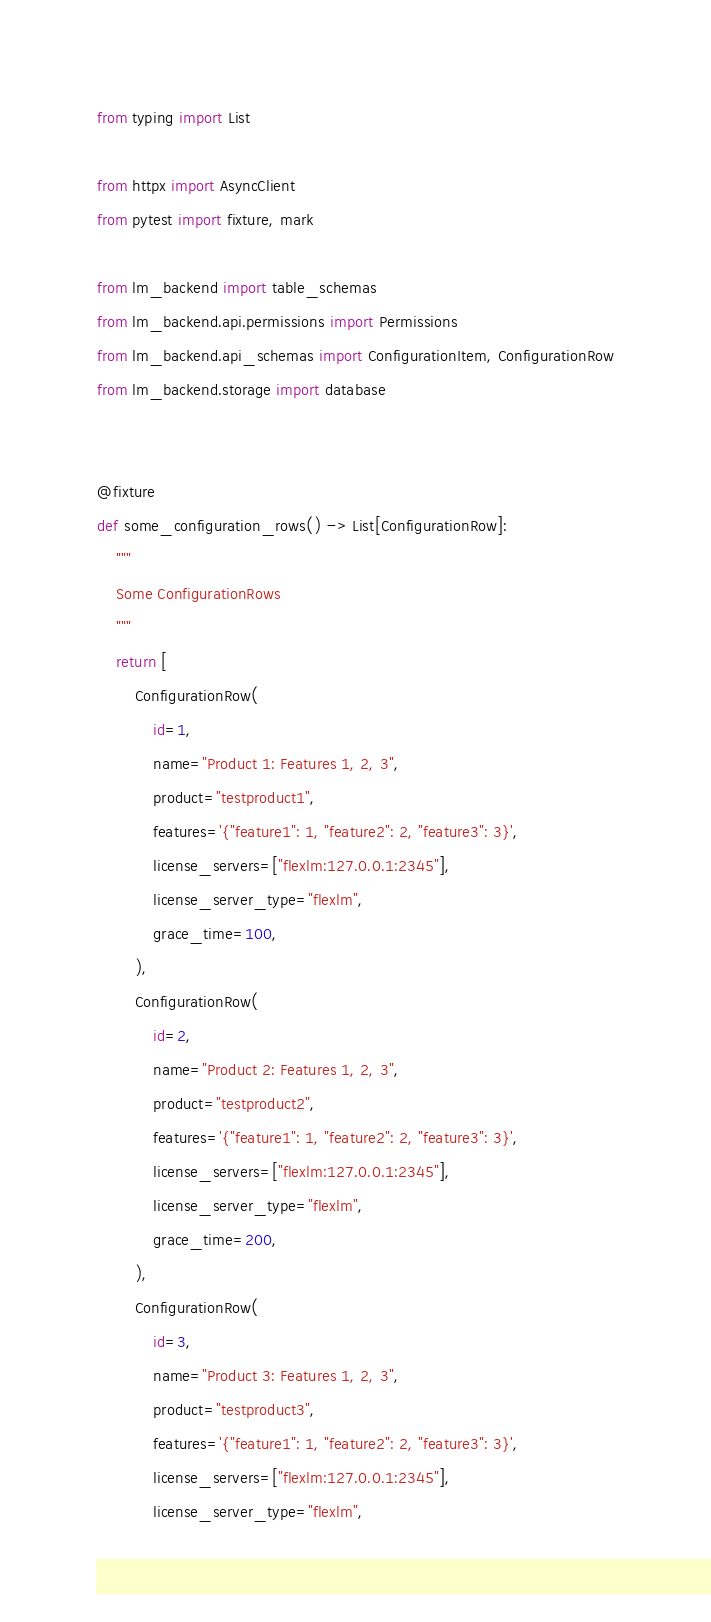Convert code to text. <code><loc_0><loc_0><loc_500><loc_500><_Python_>from typing import List

from httpx import AsyncClient
from pytest import fixture, mark

from lm_backend import table_schemas
from lm_backend.api.permissions import Permissions
from lm_backend.api_schemas import ConfigurationItem, ConfigurationRow
from lm_backend.storage import database


@fixture
def some_configuration_rows() -> List[ConfigurationRow]:
    """
    Some ConfigurationRows
    """
    return [
        ConfigurationRow(
            id=1,
            name="Product 1: Features 1, 2, 3",
            product="testproduct1",
            features='{"feature1": 1, "feature2": 2, "feature3": 3}',
            license_servers=["flexlm:127.0.0.1:2345"],
            license_server_type="flexlm",
            grace_time=100,
        ),
        ConfigurationRow(
            id=2,
            name="Product 2: Features 1, 2, 3",
            product="testproduct2",
            features='{"feature1": 1, "feature2": 2, "feature3": 3}',
            license_servers=["flexlm:127.0.0.1:2345"],
            license_server_type="flexlm",
            grace_time=200,
        ),
        ConfigurationRow(
            id=3,
            name="Product 3: Features 1, 2, 3",
            product="testproduct3",
            features='{"feature1": 1, "feature2": 2, "feature3": 3}',
            license_servers=["flexlm:127.0.0.1:2345"],
            license_server_type="flexlm",</code> 